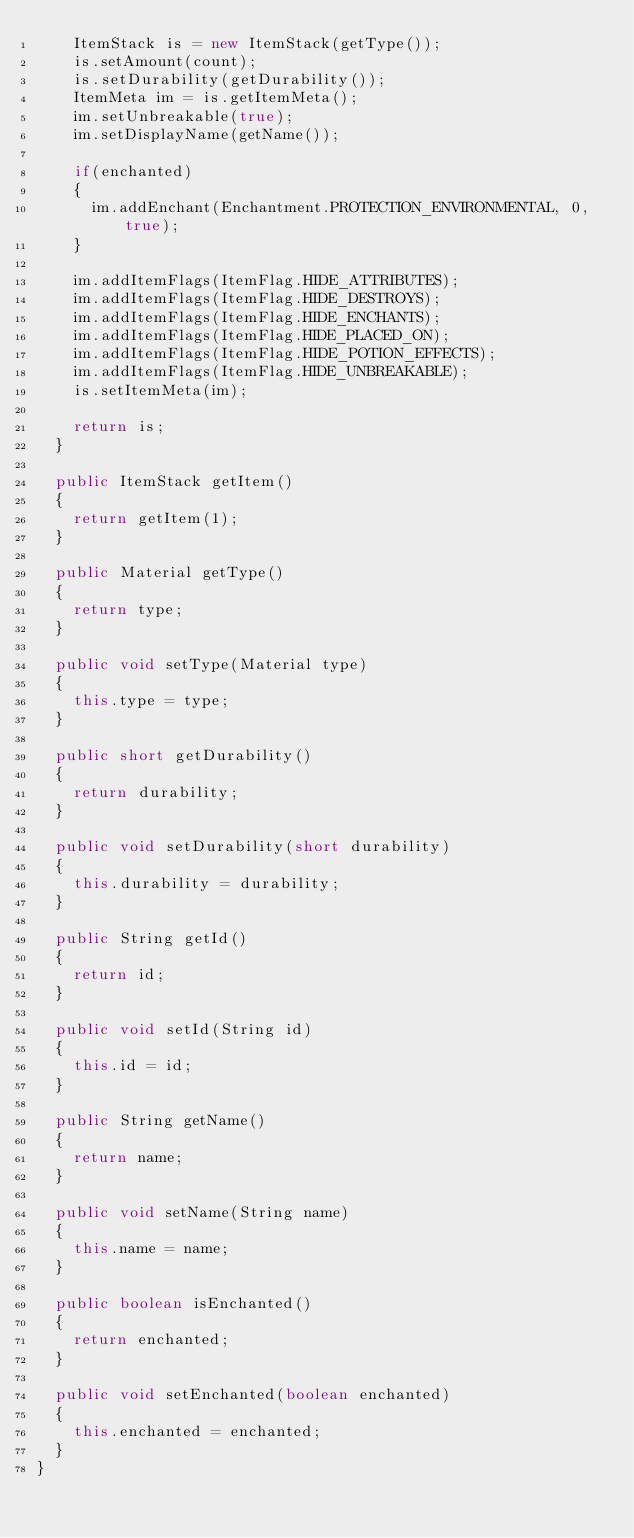<code> <loc_0><loc_0><loc_500><loc_500><_Java_>		ItemStack is = new ItemStack(getType());
		is.setAmount(count);
		is.setDurability(getDurability());
		ItemMeta im = is.getItemMeta();
		im.setUnbreakable(true);
		im.setDisplayName(getName());

		if(enchanted)
		{
			im.addEnchant(Enchantment.PROTECTION_ENVIRONMENTAL, 0, true);
		}

		im.addItemFlags(ItemFlag.HIDE_ATTRIBUTES);
		im.addItemFlags(ItemFlag.HIDE_DESTROYS);
		im.addItemFlags(ItemFlag.HIDE_ENCHANTS);
		im.addItemFlags(ItemFlag.HIDE_PLACED_ON);
		im.addItemFlags(ItemFlag.HIDE_POTION_EFFECTS);
		im.addItemFlags(ItemFlag.HIDE_UNBREAKABLE);
		is.setItemMeta(im);

		return is;
	}

	public ItemStack getItem()
	{
		return getItem(1);
	}

	public Material getType()
	{
		return type;
	}

	public void setType(Material type)
	{
		this.type = type;
	}

	public short getDurability()
	{
		return durability;
	}

	public void setDurability(short durability)
	{
		this.durability = durability;
	}

	public String getId()
	{
		return id;
	}

	public void setId(String id)
	{
		this.id = id;
	}

	public String getName()
	{
		return name;
	}

	public void setName(String name)
	{
		this.name = name;
	}

	public boolean isEnchanted()
	{
		return enchanted;
	}

	public void setEnchanted(boolean enchanted)
	{
		this.enchanted = enchanted;
	}
}
</code> 